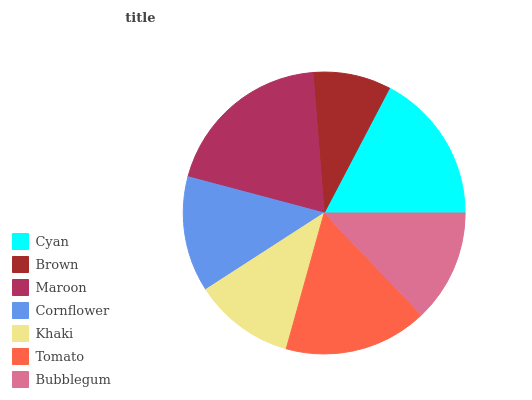Is Brown the minimum?
Answer yes or no. Yes. Is Maroon the maximum?
Answer yes or no. Yes. Is Maroon the minimum?
Answer yes or no. No. Is Brown the maximum?
Answer yes or no. No. Is Maroon greater than Brown?
Answer yes or no. Yes. Is Brown less than Maroon?
Answer yes or no. Yes. Is Brown greater than Maroon?
Answer yes or no. No. Is Maroon less than Brown?
Answer yes or no. No. Is Cornflower the high median?
Answer yes or no. Yes. Is Cornflower the low median?
Answer yes or no. Yes. Is Cyan the high median?
Answer yes or no. No. Is Cyan the low median?
Answer yes or no. No. 